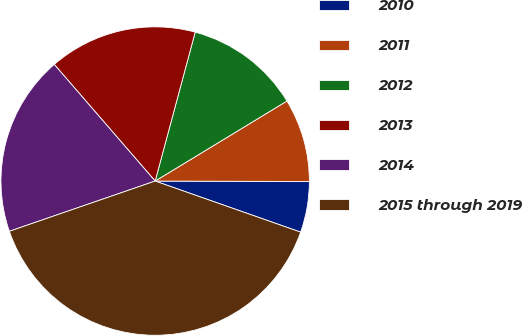Convert chart. <chart><loc_0><loc_0><loc_500><loc_500><pie_chart><fcel>2010<fcel>2011<fcel>2012<fcel>2013<fcel>2014<fcel>2015 through 2019<nl><fcel>5.33%<fcel>8.73%<fcel>12.13%<fcel>15.53%<fcel>18.93%<fcel>39.34%<nl></chart> 